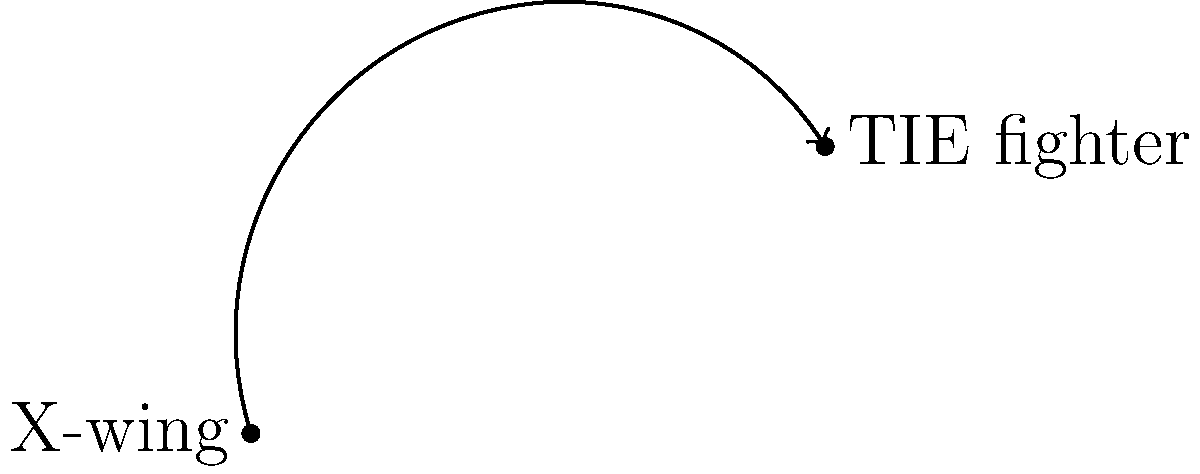An X-wing fighter at coordinates (0,0) fires proton torpedoes at a TIE fighter located at (8,4). If the torpedoes follow a parabolic trajectory with a maximum height at the midpoint between the two ships, what are the coordinates of this highest point in the trajectory? To find the coordinates of the highest point in the proton torpedo's trajectory, we can follow these steps:

1. Identify the start and end points:
   - X-wing (start): $(0,0)$
   - TIE fighter (end): $(8,4)$

2. Calculate the midpoint between the two ships:
   - $x$-coordinate: $\frac{0 + 8}{2} = 4$
   - $y$-coordinate: $\frac{0 + 4}{2} = 2$

3. The $x$-coordinate of the highest point will be the same as the midpoint: $x = 4$

4. The $y$-coordinate of the highest point will be higher than the midpoint. Since the trajectory is parabolic and symmetrical, we can assume the highest point is equidistant from the start and end points in the $y$-direction.

5. Calculate the $y$-coordinate of the highest point:
   - Vertical distance from start to end: $4 - 0 = 4$
   - Half of this distance above the midpoint: $2 + \frac{4}{2} = 4$

Therefore, the coordinates of the highest point in the trajectory are $(4,6)$.
Answer: $(4,6)$ 